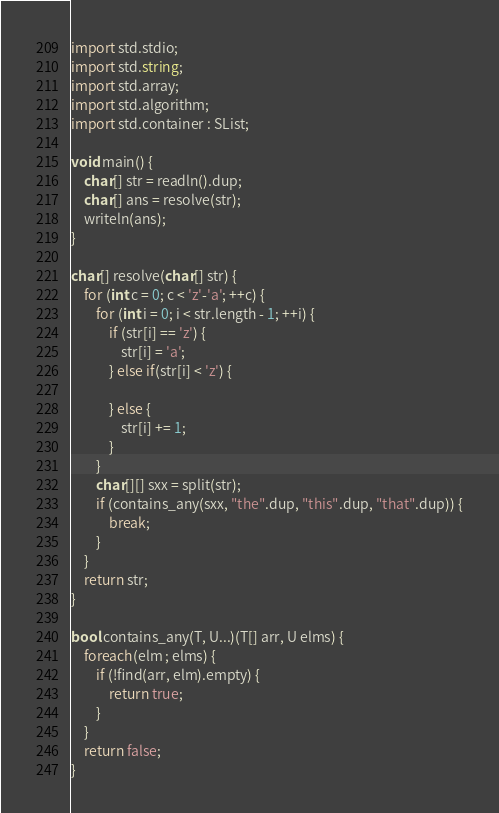Convert code to text. <code><loc_0><loc_0><loc_500><loc_500><_D_>import std.stdio;
import std.string;
import std.array;
import std.algorithm;
import std.container : SList;

void main() {
    char[] str = readln().dup;
    char[] ans = resolve(str);
    writeln(ans);
}

char[] resolve(char[] str) {
    for (int c = 0; c < 'z'-'a'; ++c) {
        for (int i = 0; i < str.length - 1; ++i) {
            if (str[i] == 'z') {
                str[i] = 'a';
            } else if(str[i] < 'z') {
                
            } else {
                str[i] += 1;
            }
        }
        char[][] sxx = split(str);
        if (contains_any(sxx, "the".dup, "this".dup, "that".dup)) {
            break;
        }
    }
    return str;
}

bool contains_any(T, U...)(T[] arr, U elms) {
    foreach(elm ; elms) {
        if (!find(arr, elm).empty) {
            return true;
        }
    }
    return false;
}</code> 